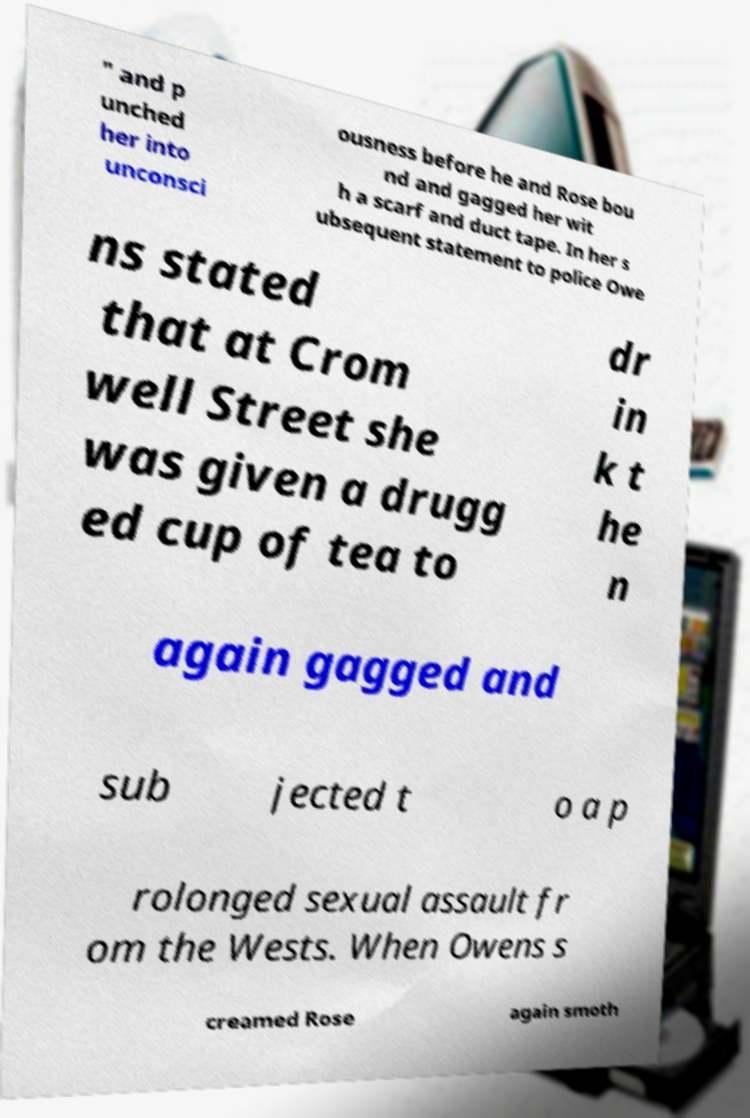What messages or text are displayed in this image? I need them in a readable, typed format. " and p unched her into unconsci ousness before he and Rose bou nd and gagged her wit h a scarf and duct tape. In her s ubsequent statement to police Owe ns stated that at Crom well Street she was given a drugg ed cup of tea to dr in k t he n again gagged and sub jected t o a p rolonged sexual assault fr om the Wests. When Owens s creamed Rose again smoth 